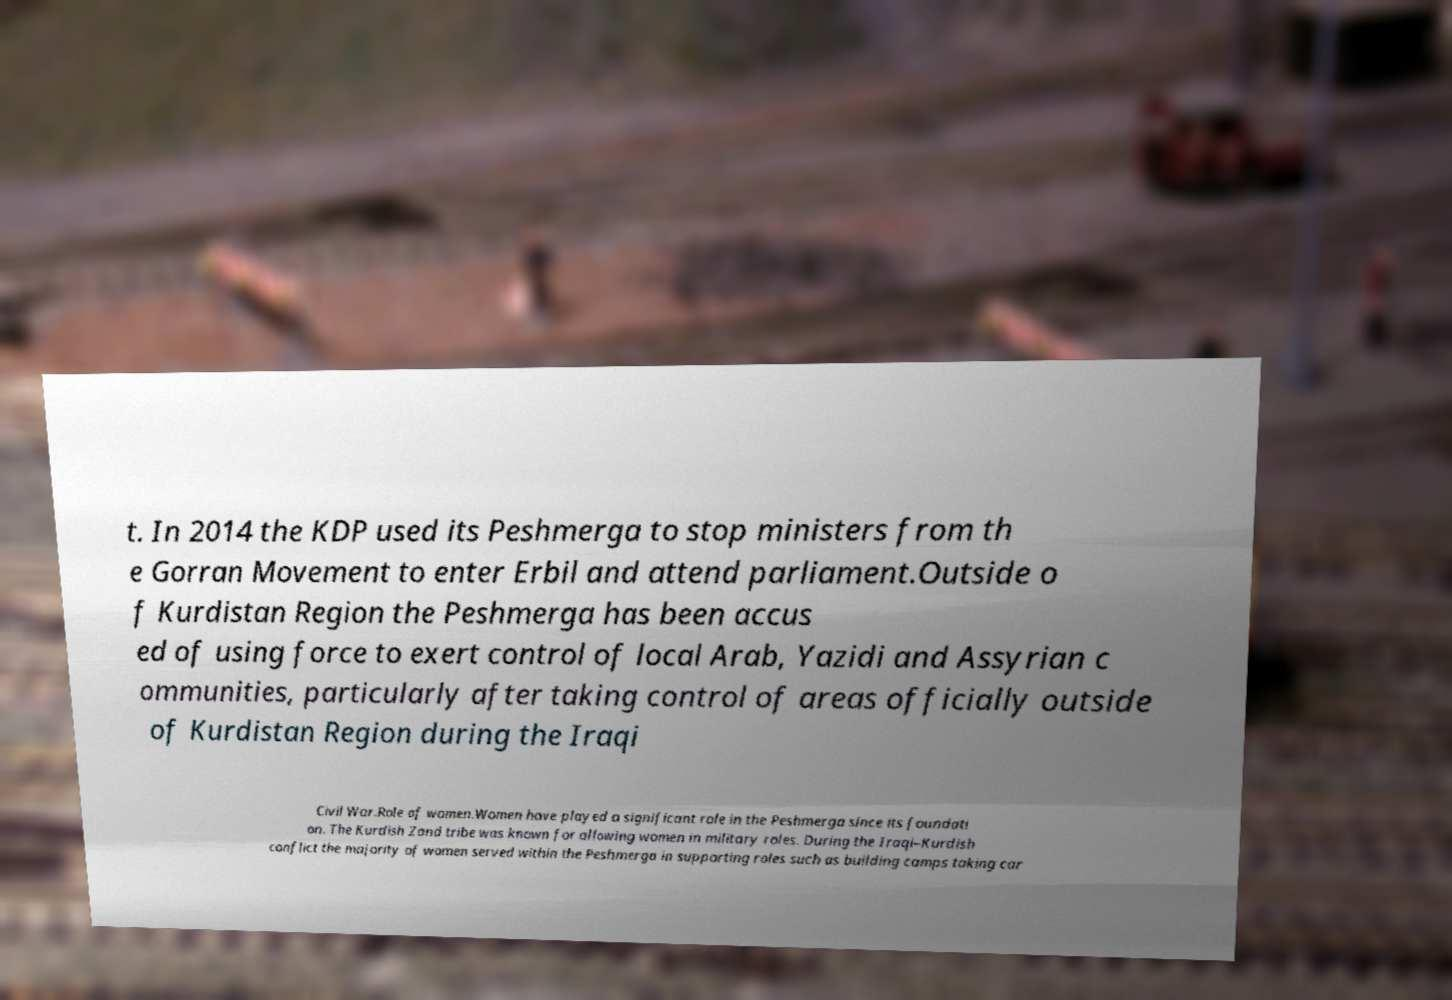Can you read and provide the text displayed in the image?This photo seems to have some interesting text. Can you extract and type it out for me? t. In 2014 the KDP used its Peshmerga to stop ministers from th e Gorran Movement to enter Erbil and attend parliament.Outside o f Kurdistan Region the Peshmerga has been accus ed of using force to exert control of local Arab, Yazidi and Assyrian c ommunities, particularly after taking control of areas officially outside of Kurdistan Region during the Iraqi Civil War.Role of women.Women have played a significant role in the Peshmerga since its foundati on. The Kurdish Zand tribe was known for allowing women in military roles. During the Iraqi–Kurdish conflict the majority of women served within the Peshmerga in supporting roles such as building camps taking car 